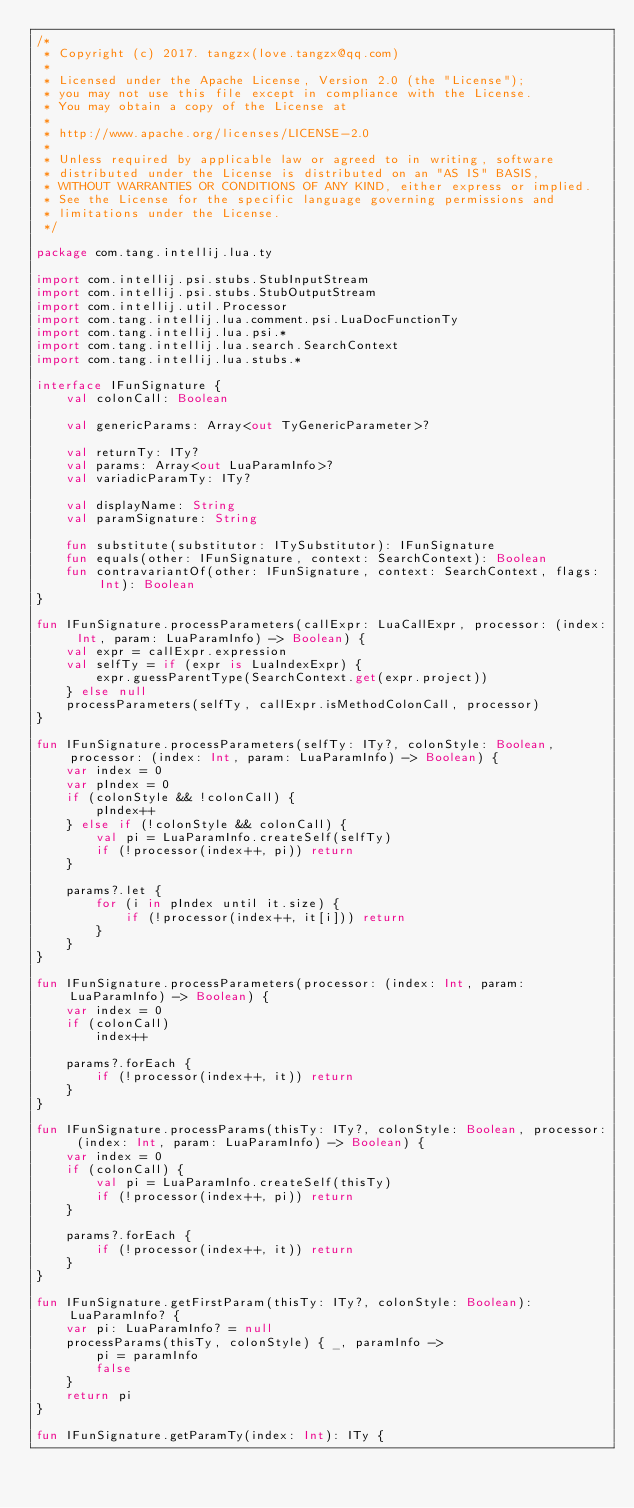<code> <loc_0><loc_0><loc_500><loc_500><_Kotlin_>/*
 * Copyright (c) 2017. tangzx(love.tangzx@qq.com)
 *
 * Licensed under the Apache License, Version 2.0 (the "License");
 * you may not use this file except in compliance with the License.
 * You may obtain a copy of the License at
 *
 * http://www.apache.org/licenses/LICENSE-2.0
 *
 * Unless required by applicable law or agreed to in writing, software
 * distributed under the License is distributed on an "AS IS" BASIS,
 * WITHOUT WARRANTIES OR CONDITIONS OF ANY KIND, either express or implied.
 * See the License for the specific language governing permissions and
 * limitations under the License.
 */

package com.tang.intellij.lua.ty

import com.intellij.psi.stubs.StubInputStream
import com.intellij.psi.stubs.StubOutputStream
import com.intellij.util.Processor
import com.tang.intellij.lua.comment.psi.LuaDocFunctionTy
import com.tang.intellij.lua.psi.*
import com.tang.intellij.lua.search.SearchContext
import com.tang.intellij.lua.stubs.*

interface IFunSignature {
    val colonCall: Boolean

    val genericParams: Array<out TyGenericParameter>?

    val returnTy: ITy?
    val params: Array<out LuaParamInfo>?
    val variadicParamTy: ITy?

    val displayName: String
    val paramSignature: String

    fun substitute(substitutor: ITySubstitutor): IFunSignature
    fun equals(other: IFunSignature, context: SearchContext): Boolean
    fun contravariantOf(other: IFunSignature, context: SearchContext, flags: Int): Boolean
}

fun IFunSignature.processParameters(callExpr: LuaCallExpr, processor: (index: Int, param: LuaParamInfo) -> Boolean) {
    val expr = callExpr.expression
    val selfTy = if (expr is LuaIndexExpr) {
        expr.guessParentType(SearchContext.get(expr.project))
    } else null
    processParameters(selfTy, callExpr.isMethodColonCall, processor)
}

fun IFunSignature.processParameters(selfTy: ITy?, colonStyle: Boolean, processor: (index: Int, param: LuaParamInfo) -> Boolean) {
    var index = 0
    var pIndex = 0
    if (colonStyle && !colonCall) {
        pIndex++
    } else if (!colonStyle && colonCall) {
        val pi = LuaParamInfo.createSelf(selfTy)
        if (!processor(index++, pi)) return
    }

    params?.let {
        for (i in pIndex until it.size) {
            if (!processor(index++, it[i])) return
        }
    }
}

fun IFunSignature.processParameters(processor: (index: Int, param: LuaParamInfo) -> Boolean) {
    var index = 0
    if (colonCall)
        index++

    params?.forEach {
        if (!processor(index++, it)) return
    }
}

fun IFunSignature.processParams(thisTy: ITy?, colonStyle: Boolean, processor: (index: Int, param: LuaParamInfo) -> Boolean) {
    var index = 0
    if (colonCall) {
        val pi = LuaParamInfo.createSelf(thisTy)
        if (!processor(index++, pi)) return
    }

    params?.forEach {
        if (!processor(index++, it)) return
    }
}

fun IFunSignature.getFirstParam(thisTy: ITy?, colonStyle: Boolean): LuaParamInfo? {
    var pi: LuaParamInfo? = null
    processParams(thisTy, colonStyle) { _, paramInfo ->
        pi = paramInfo
        false
    }
    return pi
}

fun IFunSignature.getParamTy(index: Int): ITy {</code> 